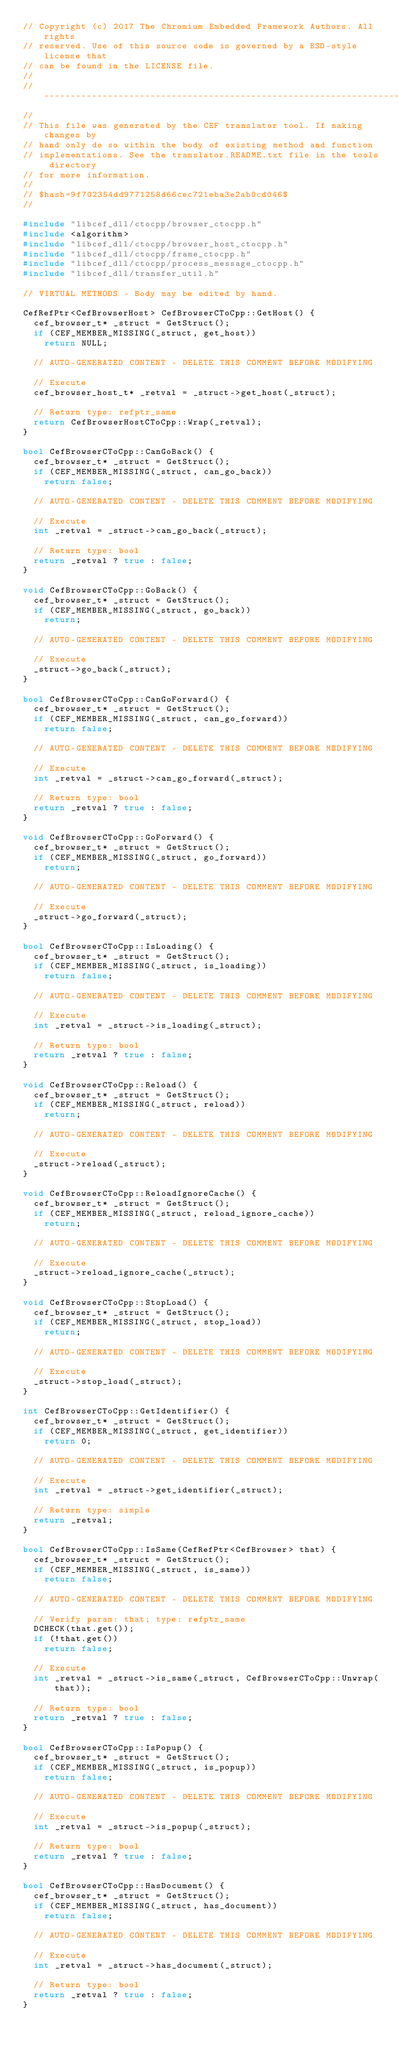<code> <loc_0><loc_0><loc_500><loc_500><_C++_>// Copyright (c) 2017 The Chromium Embedded Framework Authors. All rights
// reserved. Use of this source code is governed by a BSD-style license that
// can be found in the LICENSE file.
//
// ---------------------------------------------------------------------------
//
// This file was generated by the CEF translator tool. If making changes by
// hand only do so within the body of existing method and function
// implementations. See the translator.README.txt file in the tools directory
// for more information.
//
// $hash=9f702354dd9771258d66cec721eba3e2ab0cd046$
//

#include "libcef_dll/ctocpp/browser_ctocpp.h"
#include <algorithm>
#include "libcef_dll/ctocpp/browser_host_ctocpp.h"
#include "libcef_dll/ctocpp/frame_ctocpp.h"
#include "libcef_dll/ctocpp/process_message_ctocpp.h"
#include "libcef_dll/transfer_util.h"

// VIRTUAL METHODS - Body may be edited by hand.

CefRefPtr<CefBrowserHost> CefBrowserCToCpp::GetHost() {
  cef_browser_t* _struct = GetStruct();
  if (CEF_MEMBER_MISSING(_struct, get_host))
    return NULL;

  // AUTO-GENERATED CONTENT - DELETE THIS COMMENT BEFORE MODIFYING

  // Execute
  cef_browser_host_t* _retval = _struct->get_host(_struct);

  // Return type: refptr_same
  return CefBrowserHostCToCpp::Wrap(_retval);
}

bool CefBrowserCToCpp::CanGoBack() {
  cef_browser_t* _struct = GetStruct();
  if (CEF_MEMBER_MISSING(_struct, can_go_back))
    return false;

  // AUTO-GENERATED CONTENT - DELETE THIS COMMENT BEFORE MODIFYING

  // Execute
  int _retval = _struct->can_go_back(_struct);

  // Return type: bool
  return _retval ? true : false;
}

void CefBrowserCToCpp::GoBack() {
  cef_browser_t* _struct = GetStruct();
  if (CEF_MEMBER_MISSING(_struct, go_back))
    return;

  // AUTO-GENERATED CONTENT - DELETE THIS COMMENT BEFORE MODIFYING

  // Execute
  _struct->go_back(_struct);
}

bool CefBrowserCToCpp::CanGoForward() {
  cef_browser_t* _struct = GetStruct();
  if (CEF_MEMBER_MISSING(_struct, can_go_forward))
    return false;

  // AUTO-GENERATED CONTENT - DELETE THIS COMMENT BEFORE MODIFYING

  // Execute
  int _retval = _struct->can_go_forward(_struct);

  // Return type: bool
  return _retval ? true : false;
}

void CefBrowserCToCpp::GoForward() {
  cef_browser_t* _struct = GetStruct();
  if (CEF_MEMBER_MISSING(_struct, go_forward))
    return;

  // AUTO-GENERATED CONTENT - DELETE THIS COMMENT BEFORE MODIFYING

  // Execute
  _struct->go_forward(_struct);
}

bool CefBrowserCToCpp::IsLoading() {
  cef_browser_t* _struct = GetStruct();
  if (CEF_MEMBER_MISSING(_struct, is_loading))
    return false;

  // AUTO-GENERATED CONTENT - DELETE THIS COMMENT BEFORE MODIFYING

  // Execute
  int _retval = _struct->is_loading(_struct);

  // Return type: bool
  return _retval ? true : false;
}

void CefBrowserCToCpp::Reload() {
  cef_browser_t* _struct = GetStruct();
  if (CEF_MEMBER_MISSING(_struct, reload))
    return;

  // AUTO-GENERATED CONTENT - DELETE THIS COMMENT BEFORE MODIFYING

  // Execute
  _struct->reload(_struct);
}

void CefBrowserCToCpp::ReloadIgnoreCache() {
  cef_browser_t* _struct = GetStruct();
  if (CEF_MEMBER_MISSING(_struct, reload_ignore_cache))
    return;

  // AUTO-GENERATED CONTENT - DELETE THIS COMMENT BEFORE MODIFYING

  // Execute
  _struct->reload_ignore_cache(_struct);
}

void CefBrowserCToCpp::StopLoad() {
  cef_browser_t* _struct = GetStruct();
  if (CEF_MEMBER_MISSING(_struct, stop_load))
    return;

  // AUTO-GENERATED CONTENT - DELETE THIS COMMENT BEFORE MODIFYING

  // Execute
  _struct->stop_load(_struct);
}

int CefBrowserCToCpp::GetIdentifier() {
  cef_browser_t* _struct = GetStruct();
  if (CEF_MEMBER_MISSING(_struct, get_identifier))
    return 0;

  // AUTO-GENERATED CONTENT - DELETE THIS COMMENT BEFORE MODIFYING

  // Execute
  int _retval = _struct->get_identifier(_struct);

  // Return type: simple
  return _retval;
}

bool CefBrowserCToCpp::IsSame(CefRefPtr<CefBrowser> that) {
  cef_browser_t* _struct = GetStruct();
  if (CEF_MEMBER_MISSING(_struct, is_same))
    return false;

  // AUTO-GENERATED CONTENT - DELETE THIS COMMENT BEFORE MODIFYING

  // Verify param: that; type: refptr_same
  DCHECK(that.get());
  if (!that.get())
    return false;

  // Execute
  int _retval = _struct->is_same(_struct, CefBrowserCToCpp::Unwrap(that));

  // Return type: bool
  return _retval ? true : false;
}

bool CefBrowserCToCpp::IsPopup() {
  cef_browser_t* _struct = GetStruct();
  if (CEF_MEMBER_MISSING(_struct, is_popup))
    return false;

  // AUTO-GENERATED CONTENT - DELETE THIS COMMENT BEFORE MODIFYING

  // Execute
  int _retval = _struct->is_popup(_struct);

  // Return type: bool
  return _retval ? true : false;
}

bool CefBrowserCToCpp::HasDocument() {
  cef_browser_t* _struct = GetStruct();
  if (CEF_MEMBER_MISSING(_struct, has_document))
    return false;

  // AUTO-GENERATED CONTENT - DELETE THIS COMMENT BEFORE MODIFYING

  // Execute
  int _retval = _struct->has_document(_struct);

  // Return type: bool
  return _retval ? true : false;
}
</code> 